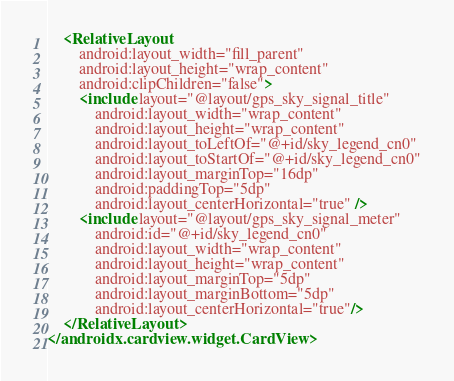Convert code to text. <code><loc_0><loc_0><loc_500><loc_500><_XML_>    <RelativeLayout
        android:layout_width="fill_parent"
        android:layout_height="wrap_content"
        android:clipChildren="false">
        <include layout="@layout/gps_sky_signal_title"
            android:layout_width="wrap_content"
            android:layout_height="wrap_content"
            android:layout_toLeftOf="@+id/sky_legend_cn0"
            android:layout_toStartOf="@+id/sky_legend_cn0"
            android:layout_marginTop="16dp"
            android:paddingTop="5dp"
            android:layout_centerHorizontal="true" />
        <include layout="@layout/gps_sky_signal_meter"
            android:id="@+id/sky_legend_cn0"
            android:layout_width="wrap_content"
            android:layout_height="wrap_content"
            android:layout_marginTop="5dp"
            android:layout_marginBottom="5dp"
            android:layout_centerHorizontal="true"/>
    </RelativeLayout>
</androidx.cardview.widget.CardView></code> 